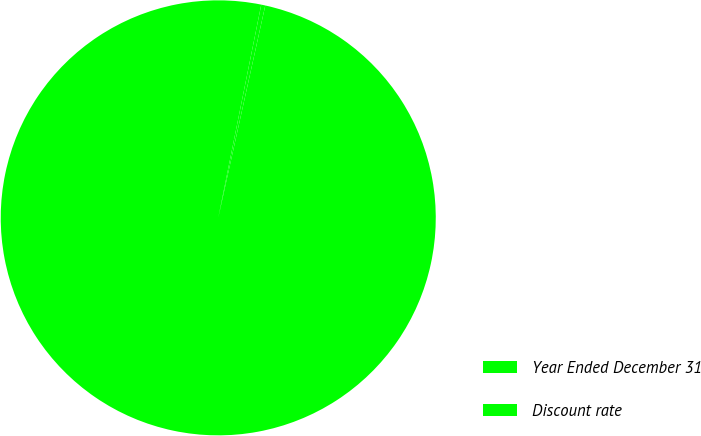Convert chart to OTSL. <chart><loc_0><loc_0><loc_500><loc_500><pie_chart><fcel>Year Ended December 31<fcel>Discount rate<nl><fcel>99.7%<fcel>0.3%<nl></chart> 